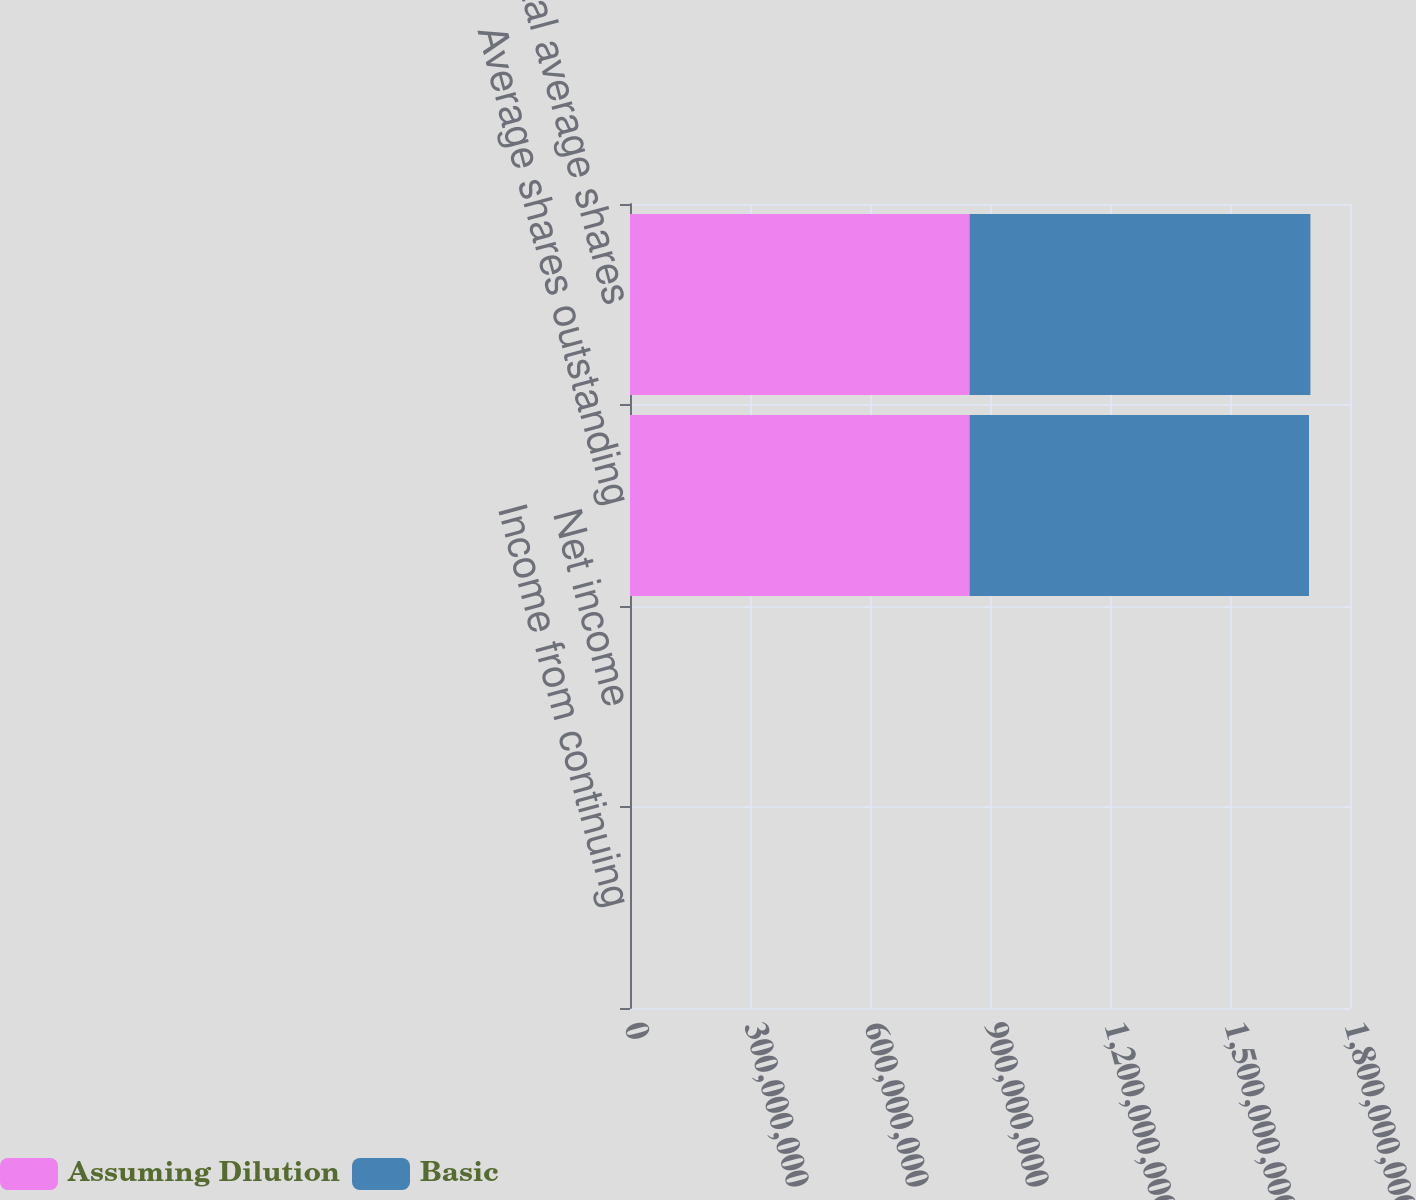Convert chart to OTSL. <chart><loc_0><loc_0><loc_500><loc_500><stacked_bar_chart><ecel><fcel>Income from continuing<fcel>Net income<fcel>Average shares outstanding<fcel>Total average shares<nl><fcel>Assuming Dilution<fcel>1581<fcel>1655<fcel>8.4874e+08<fcel>8.4874e+08<nl><fcel>Basic<fcel>1581<fcel>1655<fcel>8.4874e+08<fcel>8.52335e+08<nl></chart> 